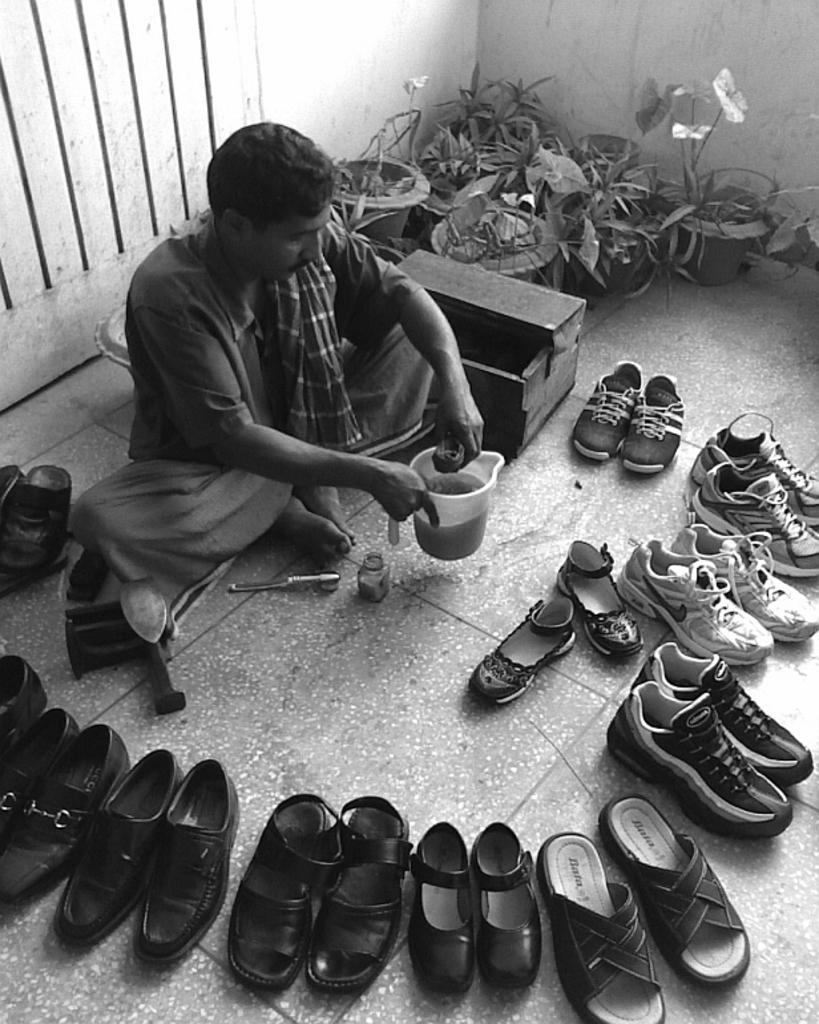In one or two sentences, can you explain what this image depicts? This is a black and white picture. In the background we can see the wall, house plants with pots. In this picture we can see a cobbler, he is holding water jug in his hands. Near to him we can see footwear, a bottle, few tools and a box. 